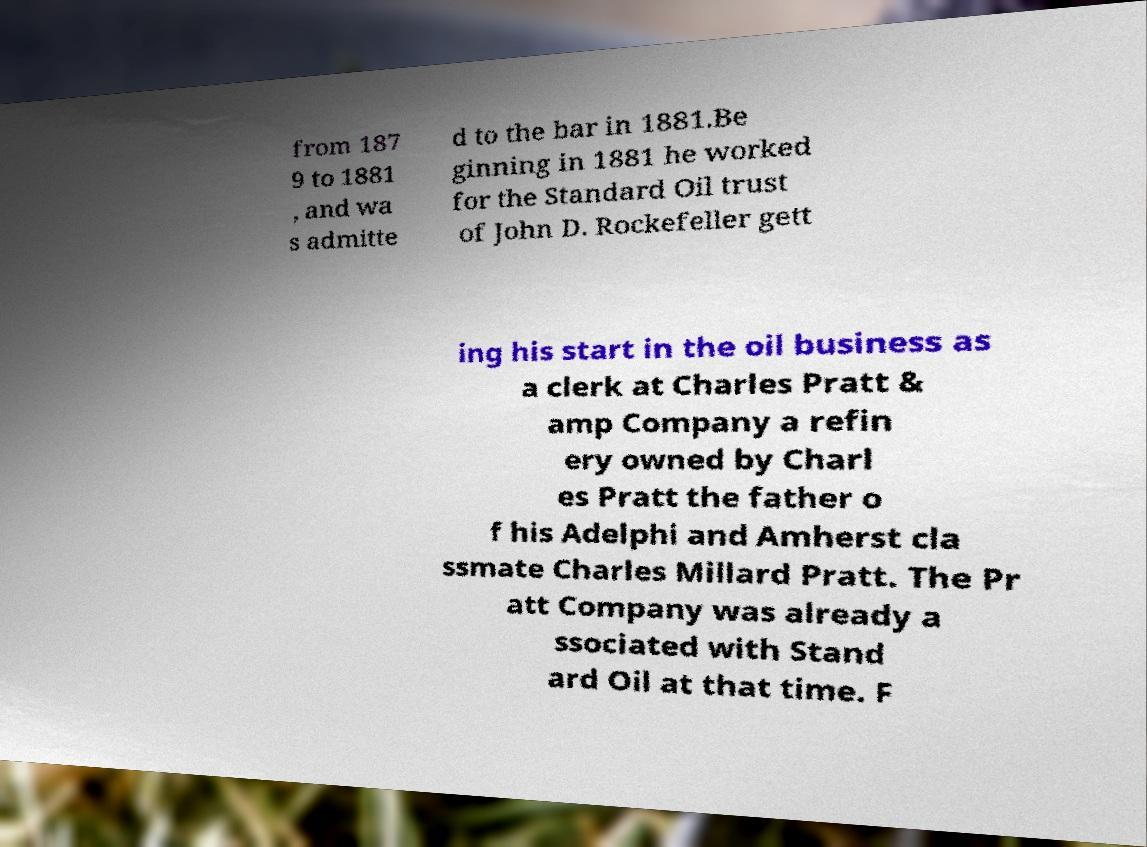Please identify and transcribe the text found in this image. from 187 9 to 1881 , and wa s admitte d to the bar in 1881.Be ginning in 1881 he worked for the Standard Oil trust of John D. Rockefeller gett ing his start in the oil business as a clerk at Charles Pratt & amp Company a refin ery owned by Charl es Pratt the father o f his Adelphi and Amherst cla ssmate Charles Millard Pratt. The Pr att Company was already a ssociated with Stand ard Oil at that time. F 